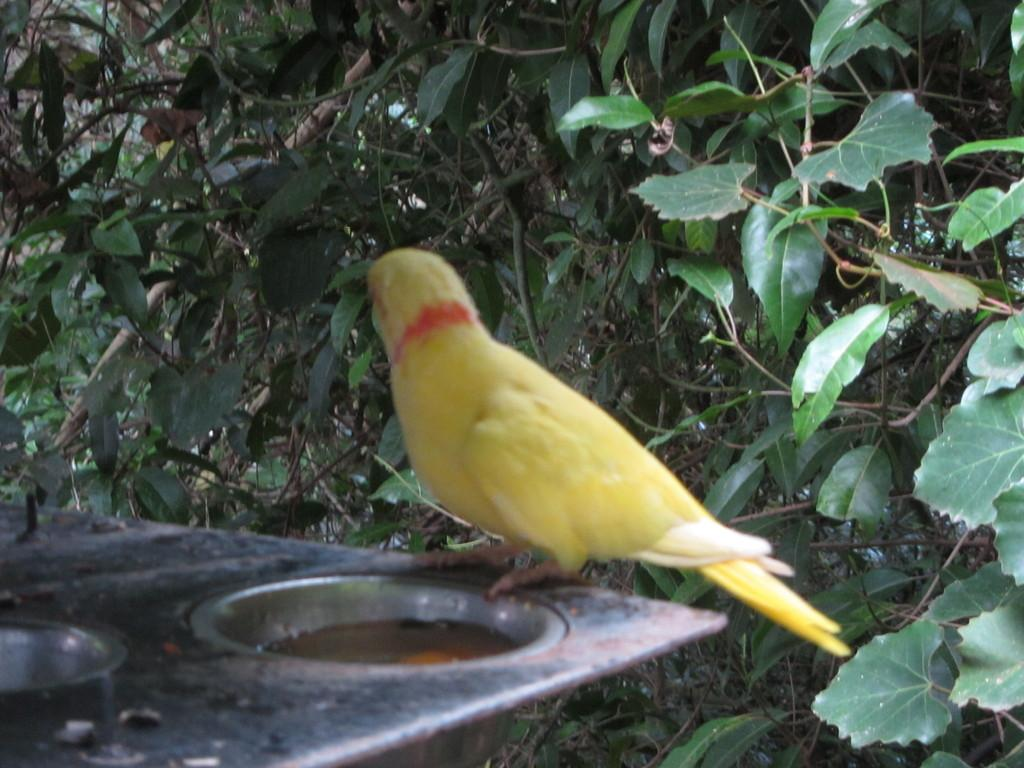What type of animal is in the image? There is a bird in the image. What is the bird standing on? The bird is standing on an object. What can be seen in the background of the image? There are many branches of a tree around the bird. What advice does the bird's aunt give about digestion in the image? There is no mention of an aunt or digestion in the image; it simply shows a bird standing on an object with branches of a tree in the background. 